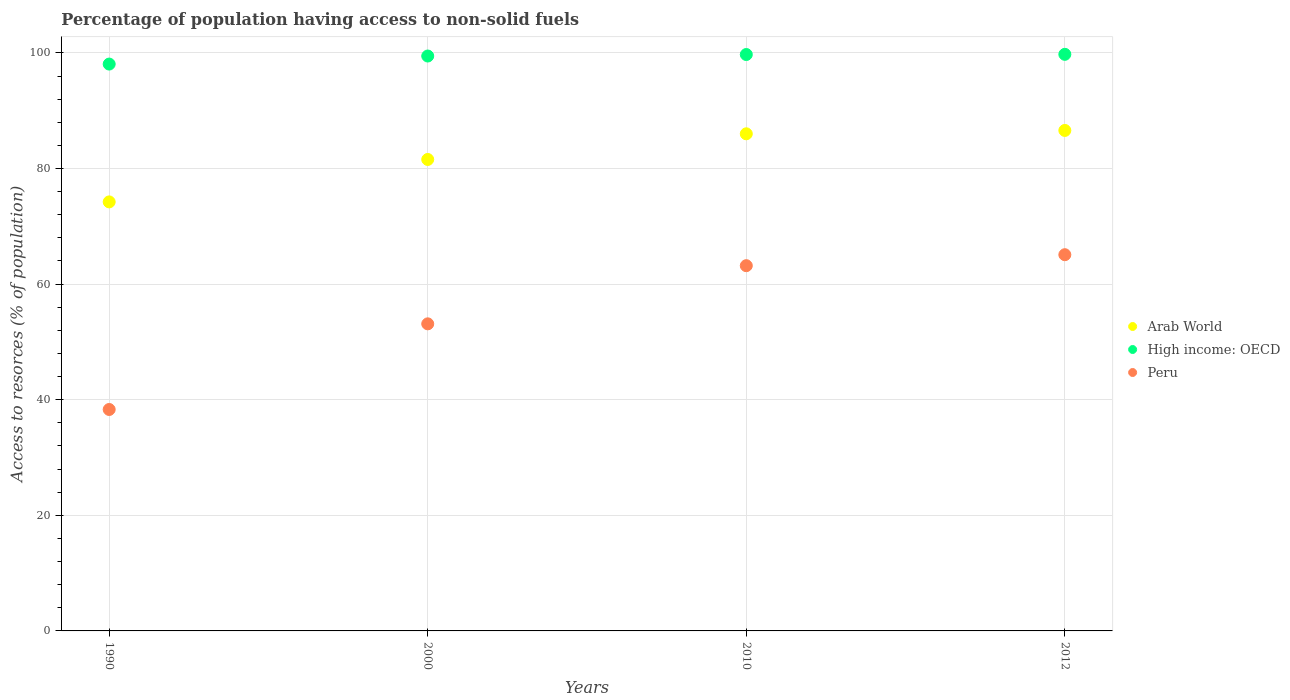Is the number of dotlines equal to the number of legend labels?
Keep it short and to the point. Yes. What is the percentage of population having access to non-solid fuels in High income: OECD in 2012?
Give a very brief answer. 99.75. Across all years, what is the maximum percentage of population having access to non-solid fuels in Peru?
Provide a short and direct response. 65.09. Across all years, what is the minimum percentage of population having access to non-solid fuels in Arab World?
Your answer should be very brief. 74.22. In which year was the percentage of population having access to non-solid fuels in Arab World minimum?
Provide a short and direct response. 1990. What is the total percentage of population having access to non-solid fuels in Peru in the graph?
Your response must be concise. 219.71. What is the difference between the percentage of population having access to non-solid fuels in Arab World in 1990 and that in 2012?
Offer a terse response. -12.36. What is the difference between the percentage of population having access to non-solid fuels in Peru in 1990 and the percentage of population having access to non-solid fuels in Arab World in 2010?
Ensure brevity in your answer.  -47.69. What is the average percentage of population having access to non-solid fuels in Arab World per year?
Ensure brevity in your answer.  82.09. In the year 1990, what is the difference between the percentage of population having access to non-solid fuels in High income: OECD and percentage of population having access to non-solid fuels in Peru?
Your answer should be compact. 59.76. In how many years, is the percentage of population having access to non-solid fuels in Peru greater than 24 %?
Offer a terse response. 4. What is the ratio of the percentage of population having access to non-solid fuels in Arab World in 1990 to that in 2012?
Give a very brief answer. 0.86. Is the percentage of population having access to non-solid fuels in High income: OECD in 1990 less than that in 2012?
Ensure brevity in your answer.  Yes. What is the difference between the highest and the second highest percentage of population having access to non-solid fuels in High income: OECD?
Offer a very short reply. 0.03. What is the difference between the highest and the lowest percentage of population having access to non-solid fuels in Peru?
Provide a short and direct response. 26.78. In how many years, is the percentage of population having access to non-solid fuels in High income: OECD greater than the average percentage of population having access to non-solid fuels in High income: OECD taken over all years?
Your response must be concise. 3. Does the percentage of population having access to non-solid fuels in Peru monotonically increase over the years?
Provide a short and direct response. Yes. Is the percentage of population having access to non-solid fuels in Arab World strictly greater than the percentage of population having access to non-solid fuels in Peru over the years?
Ensure brevity in your answer.  Yes. Is the percentage of population having access to non-solid fuels in Arab World strictly less than the percentage of population having access to non-solid fuels in Peru over the years?
Make the answer very short. No. How many dotlines are there?
Offer a very short reply. 3. How many years are there in the graph?
Offer a terse response. 4. What is the difference between two consecutive major ticks on the Y-axis?
Your response must be concise. 20. Are the values on the major ticks of Y-axis written in scientific E-notation?
Your response must be concise. No. Where does the legend appear in the graph?
Keep it short and to the point. Center right. What is the title of the graph?
Keep it short and to the point. Percentage of population having access to non-solid fuels. What is the label or title of the Y-axis?
Your answer should be very brief. Access to resorces (% of population). What is the Access to resorces (% of population) of Arab World in 1990?
Keep it short and to the point. 74.22. What is the Access to resorces (% of population) in High income: OECD in 1990?
Provide a short and direct response. 98.07. What is the Access to resorces (% of population) of Peru in 1990?
Offer a terse response. 38.31. What is the Access to resorces (% of population) in Arab World in 2000?
Make the answer very short. 81.57. What is the Access to resorces (% of population) in High income: OECD in 2000?
Make the answer very short. 99.46. What is the Access to resorces (% of population) in Peru in 2000?
Your answer should be compact. 53.13. What is the Access to resorces (% of population) in Arab World in 2010?
Offer a very short reply. 86. What is the Access to resorces (% of population) of High income: OECD in 2010?
Make the answer very short. 99.72. What is the Access to resorces (% of population) of Peru in 2010?
Your answer should be compact. 63.19. What is the Access to resorces (% of population) of Arab World in 2012?
Keep it short and to the point. 86.59. What is the Access to resorces (% of population) of High income: OECD in 2012?
Give a very brief answer. 99.75. What is the Access to resorces (% of population) of Peru in 2012?
Your response must be concise. 65.09. Across all years, what is the maximum Access to resorces (% of population) of Arab World?
Your answer should be compact. 86.59. Across all years, what is the maximum Access to resorces (% of population) of High income: OECD?
Provide a succinct answer. 99.75. Across all years, what is the maximum Access to resorces (% of population) in Peru?
Your response must be concise. 65.09. Across all years, what is the minimum Access to resorces (% of population) of Arab World?
Your response must be concise. 74.22. Across all years, what is the minimum Access to resorces (% of population) in High income: OECD?
Provide a short and direct response. 98.07. Across all years, what is the minimum Access to resorces (% of population) in Peru?
Offer a terse response. 38.31. What is the total Access to resorces (% of population) of Arab World in the graph?
Ensure brevity in your answer.  328.38. What is the total Access to resorces (% of population) in High income: OECD in the graph?
Provide a short and direct response. 397. What is the total Access to resorces (% of population) in Peru in the graph?
Your answer should be compact. 219.71. What is the difference between the Access to resorces (% of population) in Arab World in 1990 and that in 2000?
Provide a short and direct response. -7.34. What is the difference between the Access to resorces (% of population) in High income: OECD in 1990 and that in 2000?
Ensure brevity in your answer.  -1.39. What is the difference between the Access to resorces (% of population) in Peru in 1990 and that in 2000?
Keep it short and to the point. -14.82. What is the difference between the Access to resorces (% of population) in Arab World in 1990 and that in 2010?
Provide a short and direct response. -11.78. What is the difference between the Access to resorces (% of population) in High income: OECD in 1990 and that in 2010?
Provide a short and direct response. -1.65. What is the difference between the Access to resorces (% of population) of Peru in 1990 and that in 2010?
Offer a terse response. -24.88. What is the difference between the Access to resorces (% of population) of Arab World in 1990 and that in 2012?
Provide a succinct answer. -12.36. What is the difference between the Access to resorces (% of population) in High income: OECD in 1990 and that in 2012?
Keep it short and to the point. -1.69. What is the difference between the Access to resorces (% of population) in Peru in 1990 and that in 2012?
Ensure brevity in your answer.  -26.78. What is the difference between the Access to resorces (% of population) of Arab World in 2000 and that in 2010?
Provide a short and direct response. -4.44. What is the difference between the Access to resorces (% of population) in High income: OECD in 2000 and that in 2010?
Ensure brevity in your answer.  -0.26. What is the difference between the Access to resorces (% of population) in Peru in 2000 and that in 2010?
Give a very brief answer. -10.06. What is the difference between the Access to resorces (% of population) in Arab World in 2000 and that in 2012?
Give a very brief answer. -5.02. What is the difference between the Access to resorces (% of population) of High income: OECD in 2000 and that in 2012?
Give a very brief answer. -0.29. What is the difference between the Access to resorces (% of population) of Peru in 2000 and that in 2012?
Offer a terse response. -11.96. What is the difference between the Access to resorces (% of population) of Arab World in 2010 and that in 2012?
Your answer should be very brief. -0.58. What is the difference between the Access to resorces (% of population) in High income: OECD in 2010 and that in 2012?
Offer a terse response. -0.03. What is the difference between the Access to resorces (% of population) in Peru in 2010 and that in 2012?
Your answer should be very brief. -1.9. What is the difference between the Access to resorces (% of population) of Arab World in 1990 and the Access to resorces (% of population) of High income: OECD in 2000?
Your answer should be very brief. -25.24. What is the difference between the Access to resorces (% of population) of Arab World in 1990 and the Access to resorces (% of population) of Peru in 2000?
Your response must be concise. 21.1. What is the difference between the Access to resorces (% of population) of High income: OECD in 1990 and the Access to resorces (% of population) of Peru in 2000?
Your answer should be very brief. 44.94. What is the difference between the Access to resorces (% of population) of Arab World in 1990 and the Access to resorces (% of population) of High income: OECD in 2010?
Your response must be concise. -25.5. What is the difference between the Access to resorces (% of population) of Arab World in 1990 and the Access to resorces (% of population) of Peru in 2010?
Provide a short and direct response. 11.04. What is the difference between the Access to resorces (% of population) in High income: OECD in 1990 and the Access to resorces (% of population) in Peru in 2010?
Keep it short and to the point. 34.88. What is the difference between the Access to resorces (% of population) of Arab World in 1990 and the Access to resorces (% of population) of High income: OECD in 2012?
Your response must be concise. -25.53. What is the difference between the Access to resorces (% of population) of Arab World in 1990 and the Access to resorces (% of population) of Peru in 2012?
Make the answer very short. 9.14. What is the difference between the Access to resorces (% of population) in High income: OECD in 1990 and the Access to resorces (% of population) in Peru in 2012?
Ensure brevity in your answer.  32.98. What is the difference between the Access to resorces (% of population) in Arab World in 2000 and the Access to resorces (% of population) in High income: OECD in 2010?
Ensure brevity in your answer.  -18.16. What is the difference between the Access to resorces (% of population) in Arab World in 2000 and the Access to resorces (% of population) in Peru in 2010?
Give a very brief answer. 18.38. What is the difference between the Access to resorces (% of population) in High income: OECD in 2000 and the Access to resorces (% of population) in Peru in 2010?
Your response must be concise. 36.27. What is the difference between the Access to resorces (% of population) of Arab World in 2000 and the Access to resorces (% of population) of High income: OECD in 2012?
Ensure brevity in your answer.  -18.19. What is the difference between the Access to resorces (% of population) of Arab World in 2000 and the Access to resorces (% of population) of Peru in 2012?
Your response must be concise. 16.48. What is the difference between the Access to resorces (% of population) in High income: OECD in 2000 and the Access to resorces (% of population) in Peru in 2012?
Provide a short and direct response. 34.37. What is the difference between the Access to resorces (% of population) of Arab World in 2010 and the Access to resorces (% of population) of High income: OECD in 2012?
Make the answer very short. -13.75. What is the difference between the Access to resorces (% of population) of Arab World in 2010 and the Access to resorces (% of population) of Peru in 2012?
Give a very brief answer. 20.92. What is the difference between the Access to resorces (% of population) of High income: OECD in 2010 and the Access to resorces (% of population) of Peru in 2012?
Your response must be concise. 34.63. What is the average Access to resorces (% of population) of Arab World per year?
Ensure brevity in your answer.  82.09. What is the average Access to resorces (% of population) in High income: OECD per year?
Your response must be concise. 99.25. What is the average Access to resorces (% of population) of Peru per year?
Provide a succinct answer. 54.93. In the year 1990, what is the difference between the Access to resorces (% of population) of Arab World and Access to resorces (% of population) of High income: OECD?
Your answer should be very brief. -23.84. In the year 1990, what is the difference between the Access to resorces (% of population) in Arab World and Access to resorces (% of population) in Peru?
Your answer should be compact. 35.91. In the year 1990, what is the difference between the Access to resorces (% of population) in High income: OECD and Access to resorces (% of population) in Peru?
Ensure brevity in your answer.  59.76. In the year 2000, what is the difference between the Access to resorces (% of population) in Arab World and Access to resorces (% of population) in High income: OECD?
Your answer should be very brief. -17.9. In the year 2000, what is the difference between the Access to resorces (% of population) in Arab World and Access to resorces (% of population) in Peru?
Your answer should be very brief. 28.44. In the year 2000, what is the difference between the Access to resorces (% of population) of High income: OECD and Access to resorces (% of population) of Peru?
Ensure brevity in your answer.  46.33. In the year 2010, what is the difference between the Access to resorces (% of population) of Arab World and Access to resorces (% of population) of High income: OECD?
Provide a succinct answer. -13.72. In the year 2010, what is the difference between the Access to resorces (% of population) of Arab World and Access to resorces (% of population) of Peru?
Ensure brevity in your answer.  22.82. In the year 2010, what is the difference between the Access to resorces (% of population) of High income: OECD and Access to resorces (% of population) of Peru?
Give a very brief answer. 36.53. In the year 2012, what is the difference between the Access to resorces (% of population) in Arab World and Access to resorces (% of population) in High income: OECD?
Provide a succinct answer. -13.17. In the year 2012, what is the difference between the Access to resorces (% of population) in Arab World and Access to resorces (% of population) in Peru?
Ensure brevity in your answer.  21.5. In the year 2012, what is the difference between the Access to resorces (% of population) of High income: OECD and Access to resorces (% of population) of Peru?
Give a very brief answer. 34.67. What is the ratio of the Access to resorces (% of population) in Arab World in 1990 to that in 2000?
Make the answer very short. 0.91. What is the ratio of the Access to resorces (% of population) in High income: OECD in 1990 to that in 2000?
Keep it short and to the point. 0.99. What is the ratio of the Access to resorces (% of population) of Peru in 1990 to that in 2000?
Offer a very short reply. 0.72. What is the ratio of the Access to resorces (% of population) of Arab World in 1990 to that in 2010?
Ensure brevity in your answer.  0.86. What is the ratio of the Access to resorces (% of population) in High income: OECD in 1990 to that in 2010?
Your answer should be very brief. 0.98. What is the ratio of the Access to resorces (% of population) of Peru in 1990 to that in 2010?
Make the answer very short. 0.61. What is the ratio of the Access to resorces (% of population) in Arab World in 1990 to that in 2012?
Your answer should be compact. 0.86. What is the ratio of the Access to resorces (% of population) of High income: OECD in 1990 to that in 2012?
Keep it short and to the point. 0.98. What is the ratio of the Access to resorces (% of population) in Peru in 1990 to that in 2012?
Make the answer very short. 0.59. What is the ratio of the Access to resorces (% of population) of Arab World in 2000 to that in 2010?
Provide a short and direct response. 0.95. What is the ratio of the Access to resorces (% of population) of Peru in 2000 to that in 2010?
Give a very brief answer. 0.84. What is the ratio of the Access to resorces (% of population) in Arab World in 2000 to that in 2012?
Give a very brief answer. 0.94. What is the ratio of the Access to resorces (% of population) in High income: OECD in 2000 to that in 2012?
Ensure brevity in your answer.  1. What is the ratio of the Access to resorces (% of population) in Peru in 2000 to that in 2012?
Make the answer very short. 0.82. What is the ratio of the Access to resorces (% of population) in Arab World in 2010 to that in 2012?
Give a very brief answer. 0.99. What is the ratio of the Access to resorces (% of population) in Peru in 2010 to that in 2012?
Provide a short and direct response. 0.97. What is the difference between the highest and the second highest Access to resorces (% of population) in Arab World?
Offer a very short reply. 0.58. What is the difference between the highest and the second highest Access to resorces (% of population) of High income: OECD?
Your response must be concise. 0.03. What is the difference between the highest and the second highest Access to resorces (% of population) of Peru?
Give a very brief answer. 1.9. What is the difference between the highest and the lowest Access to resorces (% of population) of Arab World?
Provide a short and direct response. 12.36. What is the difference between the highest and the lowest Access to resorces (% of population) of High income: OECD?
Provide a short and direct response. 1.69. What is the difference between the highest and the lowest Access to resorces (% of population) in Peru?
Ensure brevity in your answer.  26.78. 